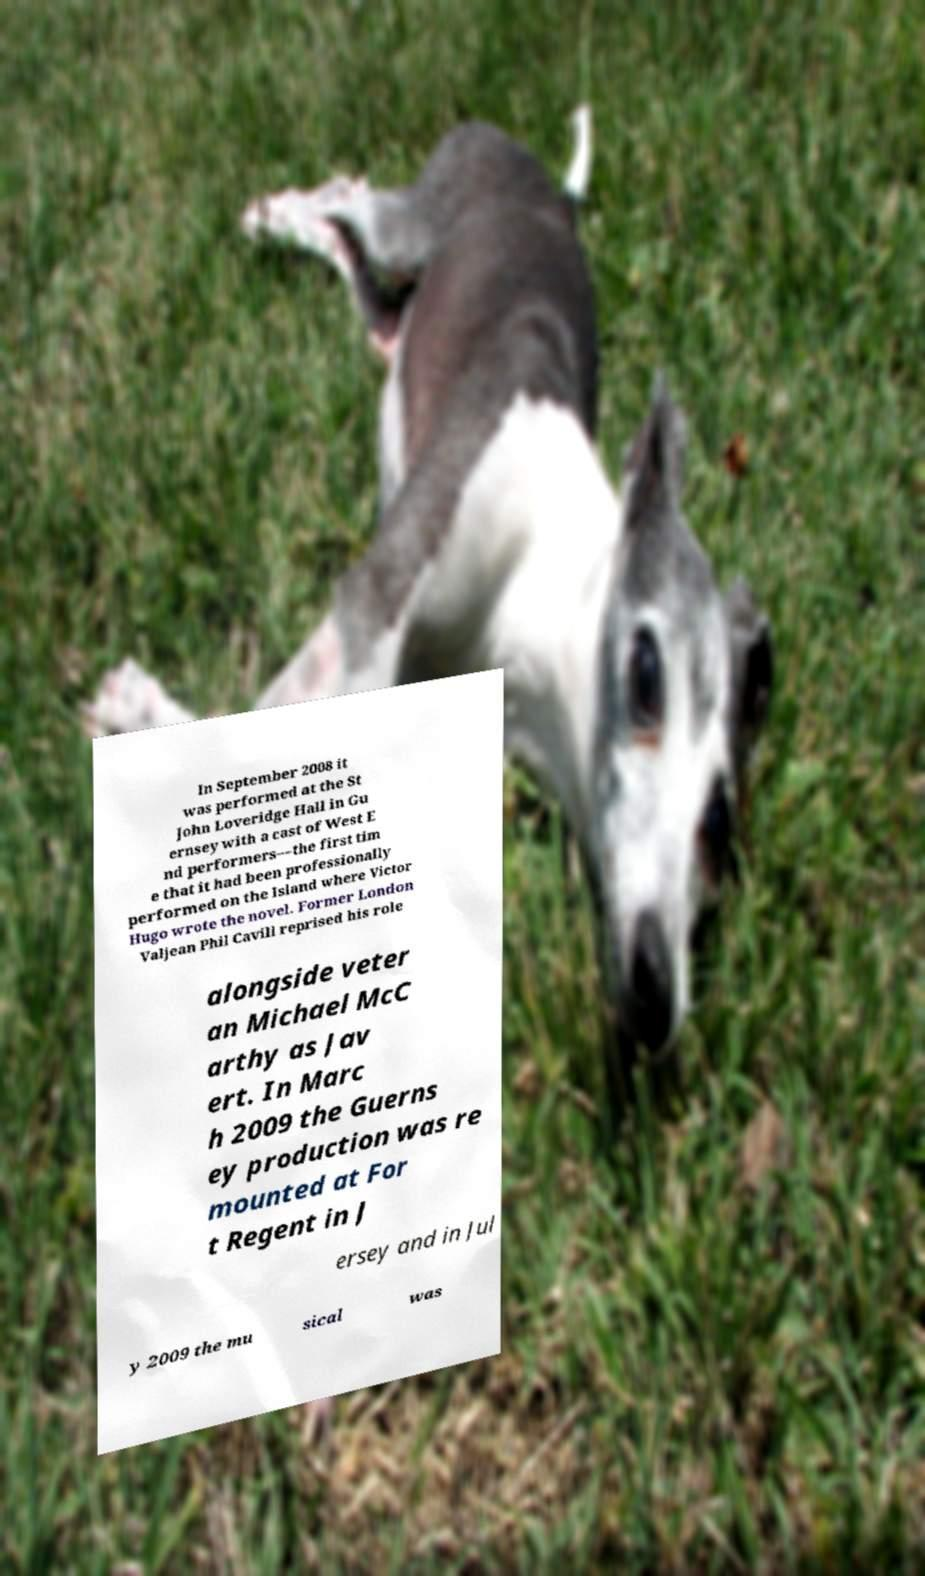Can you accurately transcribe the text from the provided image for me? In September 2008 it was performed at the St John Loveridge Hall in Gu ernsey with a cast of West E nd performers—the first tim e that it had been professionally performed on the Island where Victor Hugo wrote the novel. Former London Valjean Phil Cavill reprised his role alongside veter an Michael McC arthy as Jav ert. In Marc h 2009 the Guerns ey production was re mounted at For t Regent in J ersey and in Jul y 2009 the mu sical was 